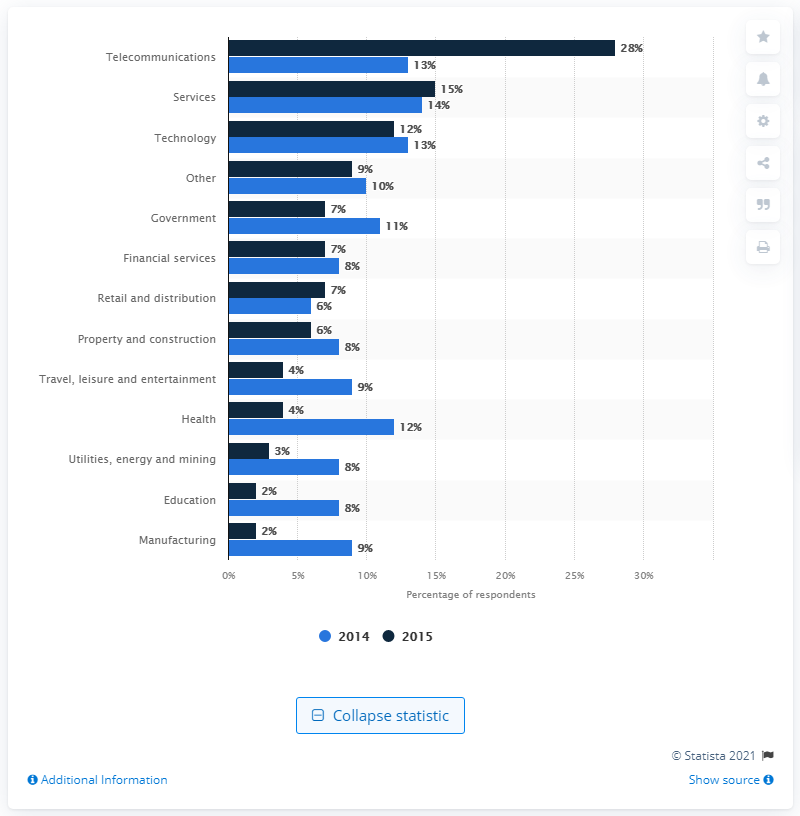Mention a couple of crucial points in this snapshot. In 2014, the service sector spent approximately 7.6% of their IT budget on security. 